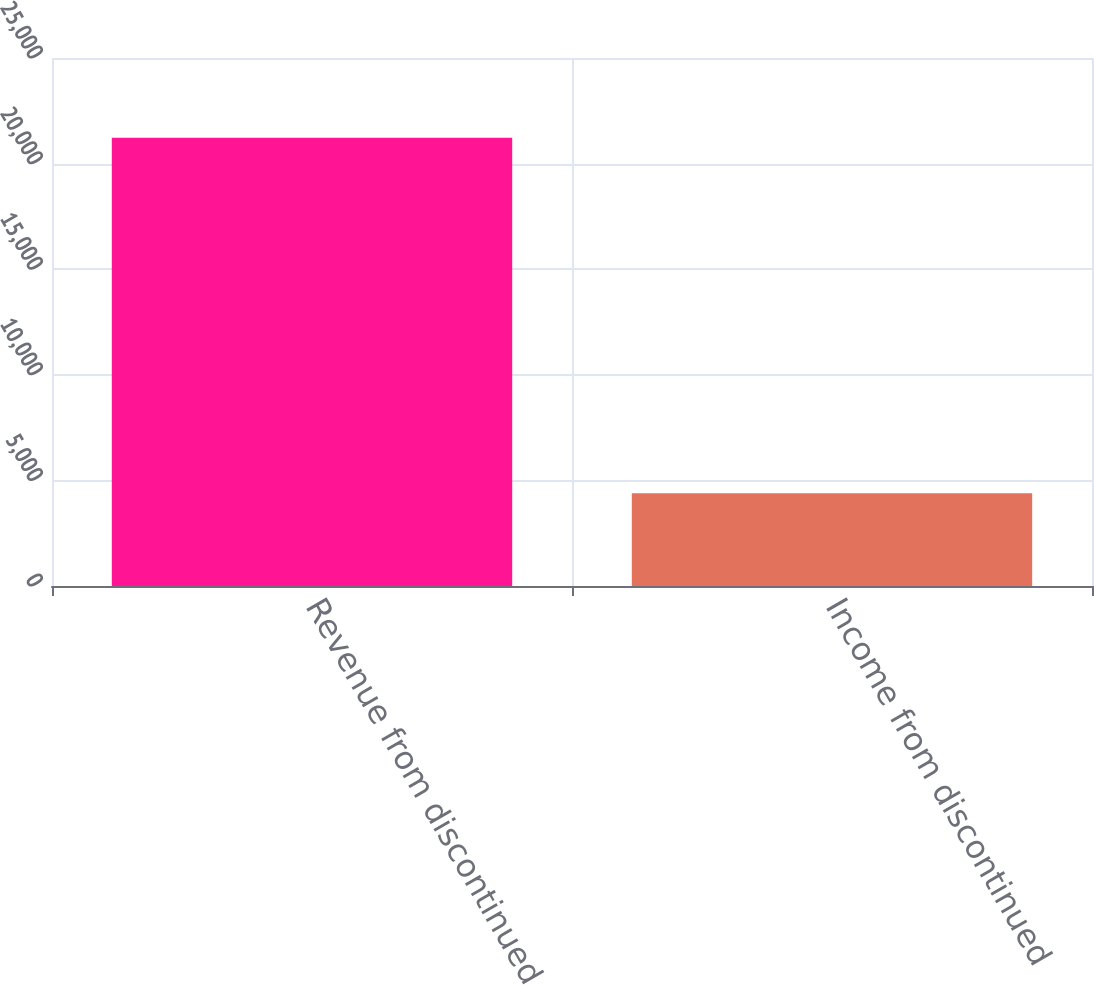<chart> <loc_0><loc_0><loc_500><loc_500><bar_chart><fcel>Revenue from discontinued<fcel>Income from discontinued<nl><fcel>21221<fcel>4389<nl></chart> 